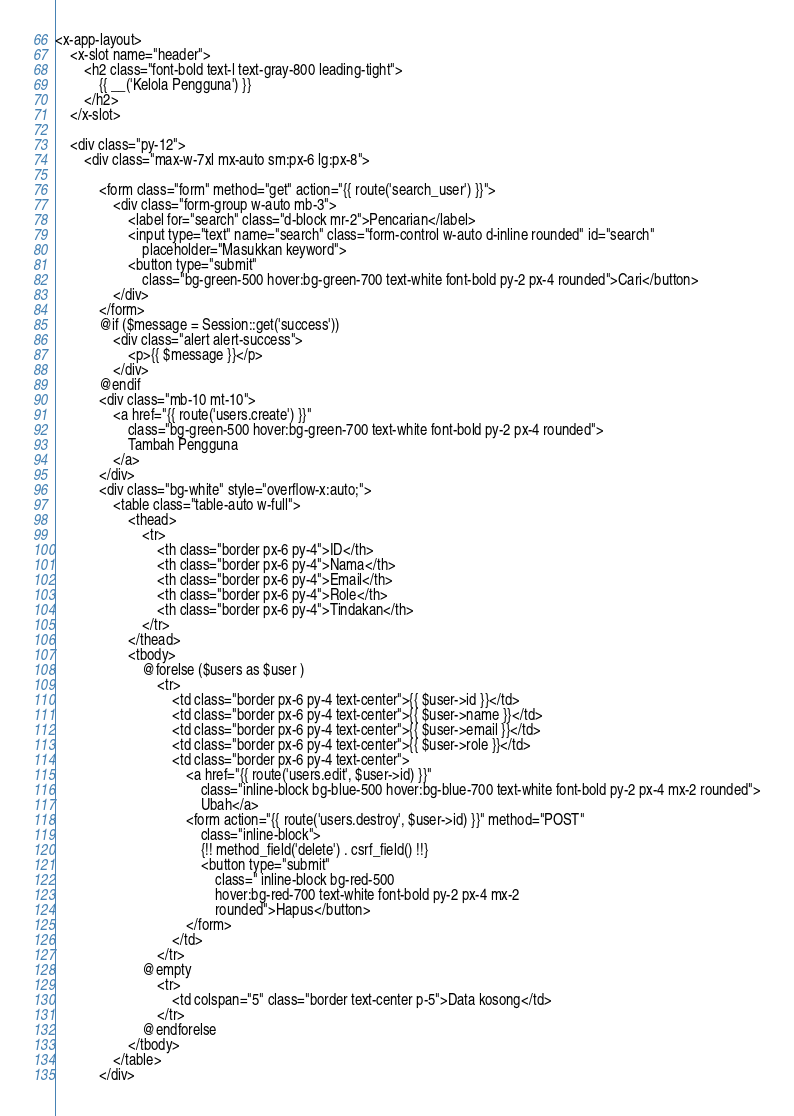Convert code to text. <code><loc_0><loc_0><loc_500><loc_500><_PHP_><x-app-layout>
    <x-slot name="header">
        <h2 class="font-bold text-l text-gray-800 leading-tight">
            {{ __('Kelola Pengguna') }}
        </h2>
    </x-slot>

    <div class="py-12">
        <div class="max-w-7xl mx-auto sm:px-6 lg:px-8">

            <form class="form" method="get" action="{{ route('search_user') }}">
                <div class="form-group w-auto mb-3">
                    <label for="search" class="d-block mr-2">Pencarian</label>
                    <input type="text" name="search" class="form-control w-auto d-inline rounded" id="search"
                        placeholder="Masukkan keyword">
                    <button type="submit"
                        class="bg-green-500 hover:bg-green-700 text-white font-bold py-2 px-4 rounded">Cari</button>
                </div>
            </form>
            @if ($message = Session::get('success'))
                <div class="alert alert-success">
                    <p>{{ $message }}</p>
                </div>
            @endif
            <div class="mb-10 mt-10">
                <a href="{{ route('users.create') }}"
                    class="bg-green-500 hover:bg-green-700 text-white font-bold py-2 px-4 rounded">
                    Tambah Pengguna
                </a>
            </div>
            <div class="bg-white" style="overflow-x:auto;">
                <table class="table-auto w-full">
                    <thead>
                        <tr>
                            <th class="border px-6 py-4">ID</th>
                            <th class="border px-6 py-4">Nama</th>
                            <th class="border px-6 py-4">Email</th>
                            <th class="border px-6 py-4">Role</th>
                            <th class="border px-6 py-4">Tindakan</th>
                        </tr>
                    </thead>
                    <tbody>
                        @forelse ($users as $user )
                            <tr>
                                <td class="border px-6 py-4 text-center">{{ $user->id }}</td>
                                <td class="border px-6 py-4 text-center">{{ $user->name }}</td>
                                <td class="border px-6 py-4 text-center">{{ $user->email }}</td>
                                <td class="border px-6 py-4 text-center">{{ $user->role }}</td>
                                <td class="border px-6 py-4 text-center">
                                    <a href="{{ route('users.edit', $user->id) }}"
                                        class="inline-block bg-blue-500 hover:bg-blue-700 text-white font-bold py-2 px-4 mx-2 rounded">
                                        Ubah</a>
                                    <form action="{{ route('users.destroy', $user->id) }}" method="POST"
                                        class="inline-block">
                                        {!! method_field('delete') . csrf_field() !!}
                                        <button type="submit"
                                            class=" inline-block bg-red-500
                                            hover:bg-red-700 text-white font-bold py-2 px-4 mx-2
                                            rounded">Hapus</button>
                                    </form>
                                </td>
                            </tr>
                        @empty
                            <tr>
                                <td colspan="5" class="border text-center p-5">Data kosong</td>
                            </tr>
                        @endforelse
                    </tbody>
                </table>
            </div></code> 